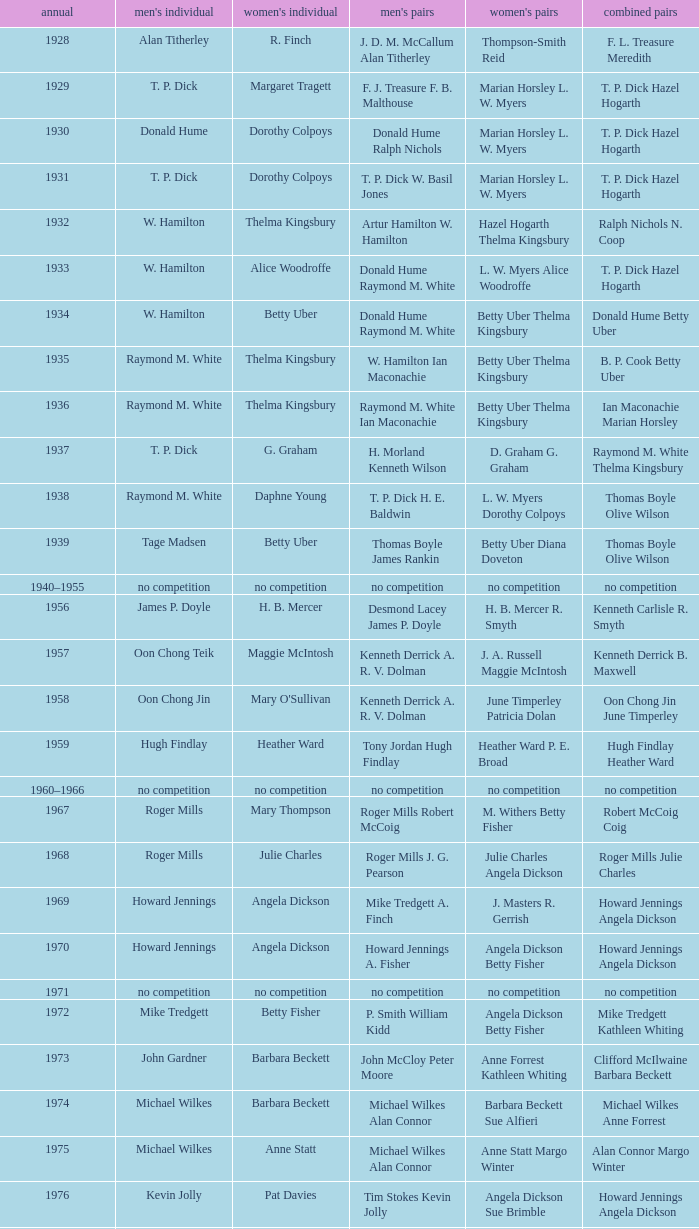Who won the Women's singles, in the year that Raymond M. White won the Men's singles and that W. Hamilton Ian Maconachie won the Men's doubles? Thelma Kingsbury. 